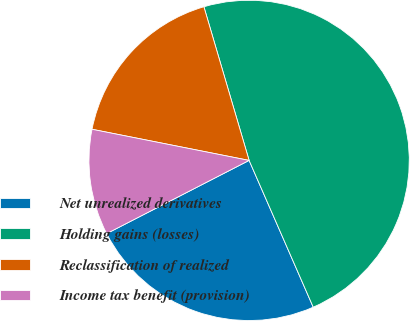Convert chart. <chart><loc_0><loc_0><loc_500><loc_500><pie_chart><fcel>Net unrealized derivatives<fcel>Holding gains (losses)<fcel>Reclassification of realized<fcel>Income tax benefit (provision)<nl><fcel>24.0%<fcel>48.0%<fcel>17.33%<fcel>10.67%<nl></chart> 